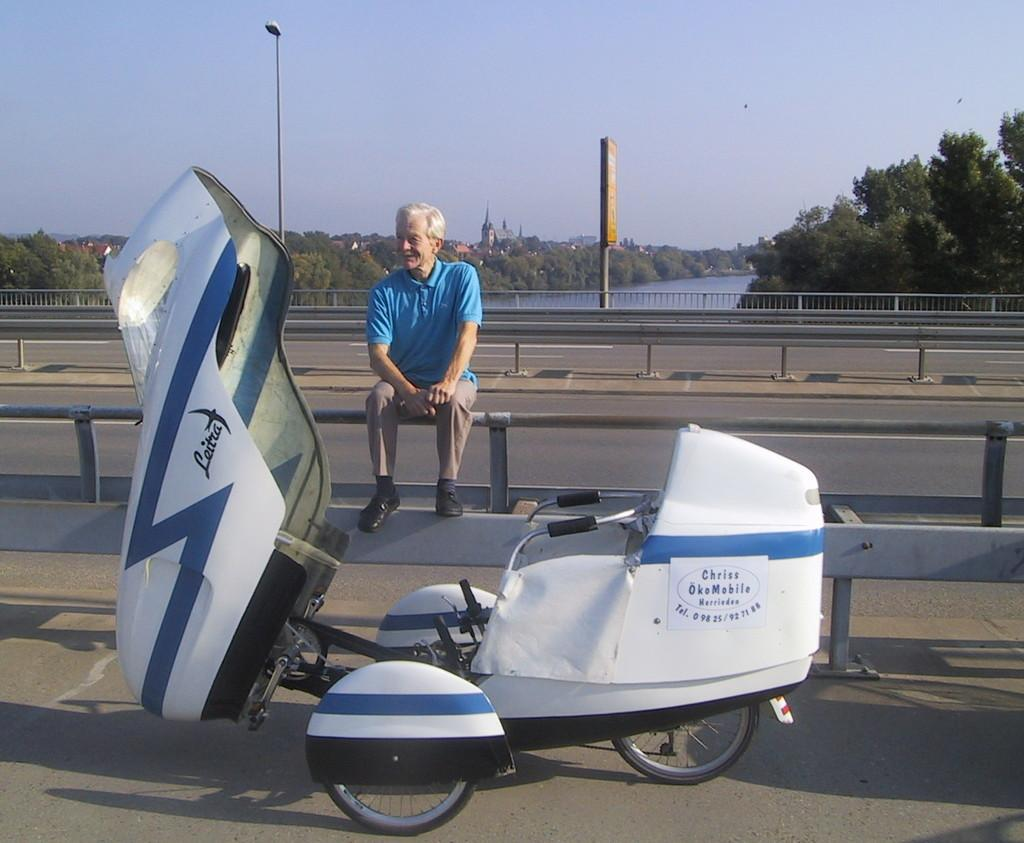<image>
Relay a brief, clear account of the picture shown. A man sits near a fancy tricycle that says Leitia on it. 